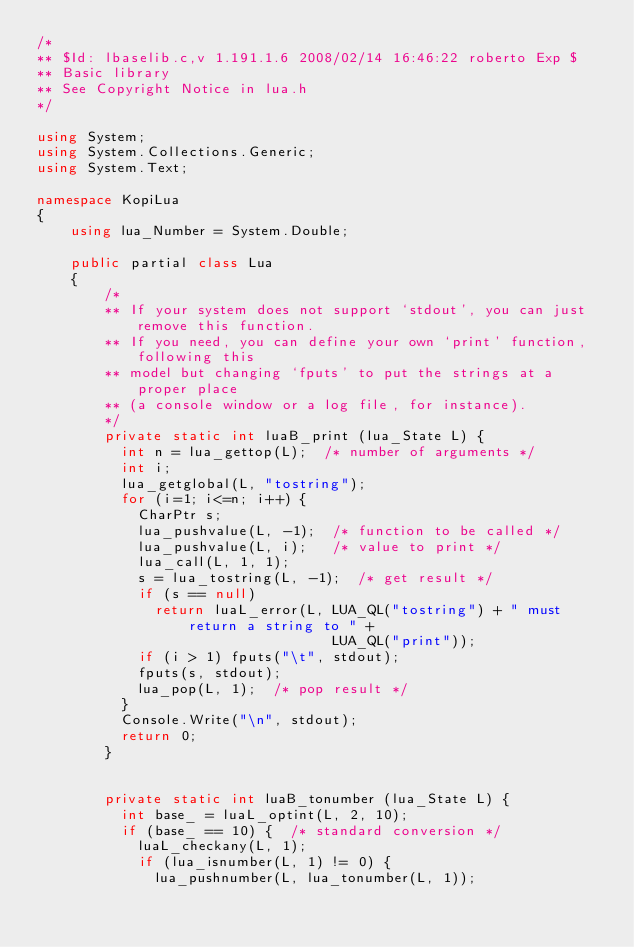Convert code to text. <code><loc_0><loc_0><loc_500><loc_500><_C#_>/*
** $Id: lbaselib.c,v 1.191.1.6 2008/02/14 16:46:22 roberto Exp $
** Basic library
** See Copyright Notice in lua.h
*/

using System;
using System.Collections.Generic;
using System.Text;

namespace KopiLua
{
	using lua_Number = System.Double;

	public partial class Lua
	{
		/*
		** If your system does not support `stdout', you can just remove this function.
		** If you need, you can define your own `print' function, following this
		** model but changing `fputs' to put the strings at a proper place
		** (a console window or a log file, for instance).
		*/
		private static int luaB_print (lua_State L) {
		  int n = lua_gettop(L);  /* number of arguments */
		  int i;
		  lua_getglobal(L, "tostring");
		  for (i=1; i<=n; i++) {
			CharPtr s;
			lua_pushvalue(L, -1);  /* function to be called */
			lua_pushvalue(L, i);   /* value to print */
			lua_call(L, 1, 1);
			s = lua_tostring(L, -1);  /* get result */
			if (s == null)
			  return luaL_error(L, LUA_QL("tostring") + " must return a string to " +
								   LUA_QL("print"));
			if (i > 1) fputs("\t", stdout);
			fputs(s, stdout);
			lua_pop(L, 1);  /* pop result */
		  }
		  Console.Write("\n", stdout);
		  return 0;
		}


		private static int luaB_tonumber (lua_State L) {
		  int base_ = luaL_optint(L, 2, 10);
		  if (base_ == 10) {  /* standard conversion */
			luaL_checkany(L, 1);
			if (lua_isnumber(L, 1) != 0) {
			  lua_pushnumber(L, lua_tonumber(L, 1));</code> 